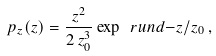<formula> <loc_0><loc_0><loc_500><loc_500>p _ { z } ( z ) = \frac { z ^ { 2 } } { 2 \, z _ { 0 } ^ { 3 } } \exp \ r u n d { - z / z _ { 0 } } \, ,</formula> 